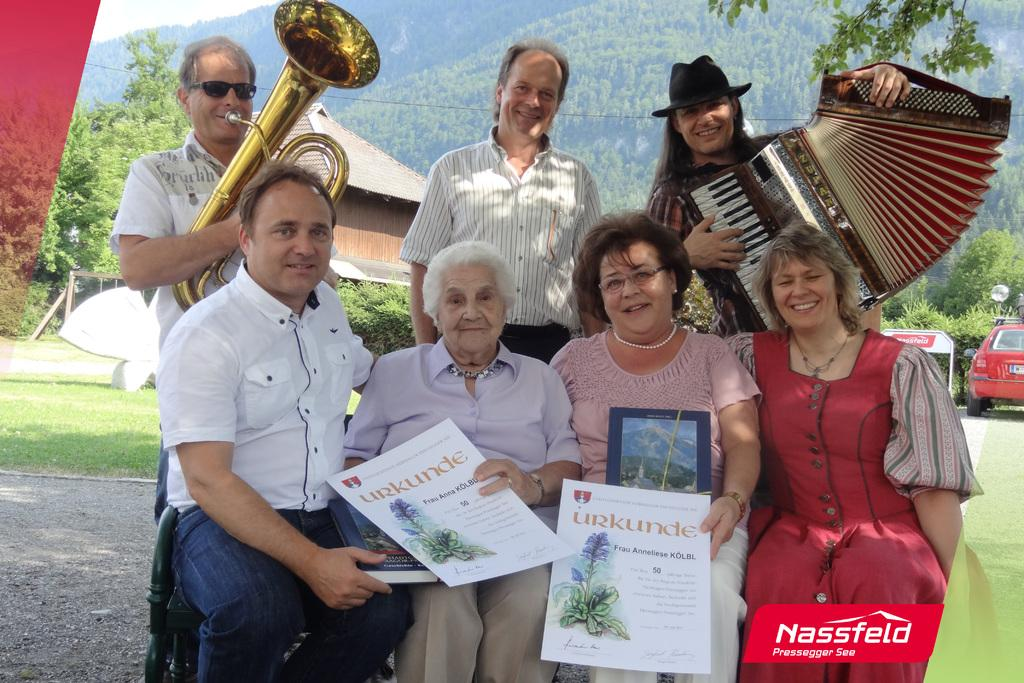<image>
Create a compact narrative representing the image presented. A family, some of whom are playing instruments, are displayed with the brand Nassfel in the corner 